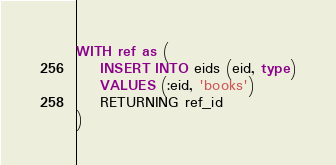Convert code to text. <code><loc_0><loc_0><loc_500><loc_500><_SQL_>WITH ref as (
    INSERT INTO eids (eid, type)
    VALUES (:eid, 'books')
    RETURNING ref_id
)</code> 